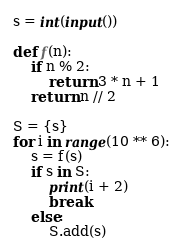Convert code to text. <code><loc_0><loc_0><loc_500><loc_500><_Python_>s = int(input())

def f(n):
    if n % 2:
        return 3 * n + 1
    return n // 2

S = {s}
for i in range(10 ** 6):
    s = f(s)
    if s in S:
        print(i + 2)
        break
    else:
        S.add(s)

</code> 